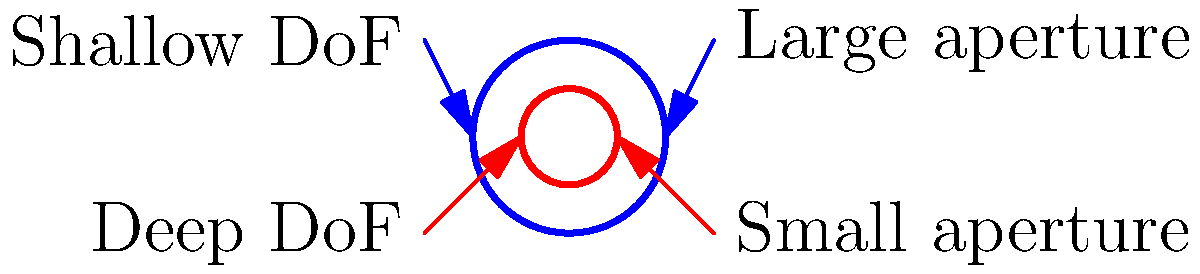As a photographer challenging societal beauty standards with raw, unedited images, you're exploring the relationship between aperture size and depth of field. Given the diagram, which shows two aperture sizes and their corresponding depth of field (DoF), how does the f-number relate to the aperture diameter? If the larger aperture has an f-number of f/2.8, what would be the approximate f-number of the smaller aperture? To solve this problem, let's follow these steps:

1. Understand the relationship between f-number and aperture diameter:
   The f-number is inversely proportional to the aperture diameter. 
   Mathematically, this is expressed as: $f-number \propto \frac{1}{aperture diameter}$

2. Observe the diagram:
   The larger circle represents a larger aperture (smaller f-number).
   The smaller circle represents a smaller aperture (larger f-number).

3. Compare the diameters:
   The smaller aperture appears to have about half the diameter of the larger aperture.

4. Use the inverse relationship:
   If the diameter is halved, the f-number should double.

5. Calculate the new f-number:
   Given: Larger aperture f-number = f/2.8
   Smaller aperture f-number ≈ 2 × 2.8 = 5.6

Therefore, the approximate f-number of the smaller aperture would be f/5.6.

This relationship illustrates why larger apertures (smaller f-numbers) create a shallower depth of field, allowing for more creative control in challenging beauty standards through photography.
Answer: f/5.6 